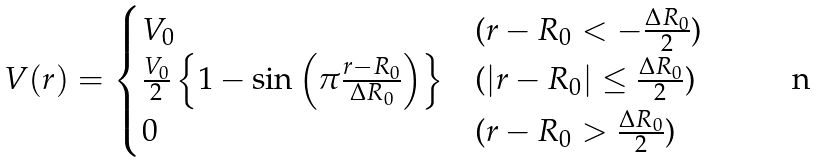Convert formula to latex. <formula><loc_0><loc_0><loc_500><loc_500>V ( r ) = \begin{cases} V _ { 0 } & \text {($r-R_{0} <-\frac{\Delta R_{0}}{2}$)} \\ \frac { V _ { 0 } } { 2 } \left \{ 1 - \sin \left ( \pi \frac { r - R _ { 0 } } { \Delta R _ { 0 } } \right ) \right \} & \text {($|r-R_{0} |\leq \frac{\Delta R_{0}}{2}$)} \\ 0 & \text {($r-R_{0} >\frac{\Delta R_{0}}{2}$)} \end{cases}</formula> 